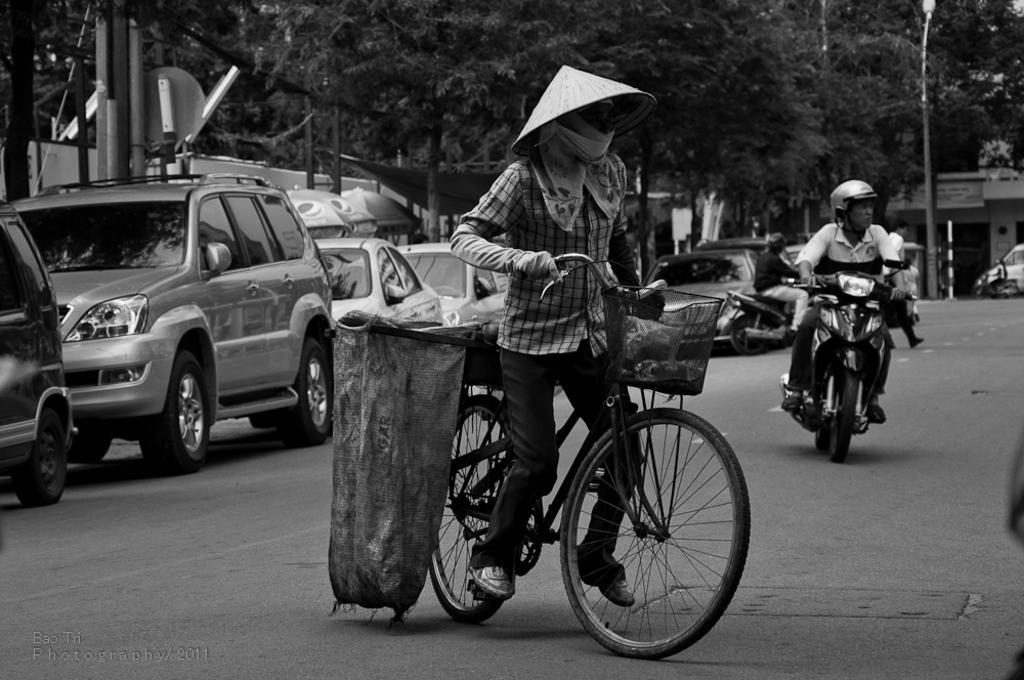Could you give a brief overview of what you see in this image? In this image I can see few people where one is with his cycle and rest all are on their bikes. In the background I can see number of vehicles, trees, a street light and few buildings. 